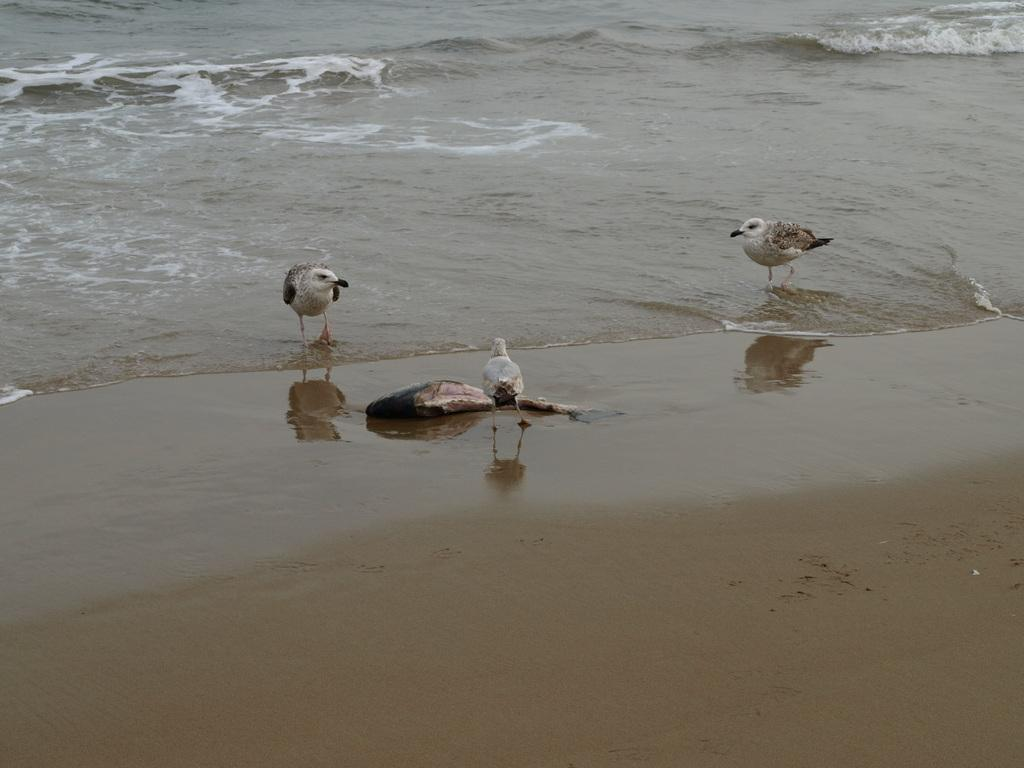What type of animals can be seen in the front of the image? There are birds in the front of the image. What can be seen in the background of the image? There is water visible in the background of the image. What is located on the ground in the image? There is an object on the ground in the image. What is the color of the object on the ground? The object is black in color. How many babies are playing with the instrument in the image? There are no babies or instruments present in the image. 